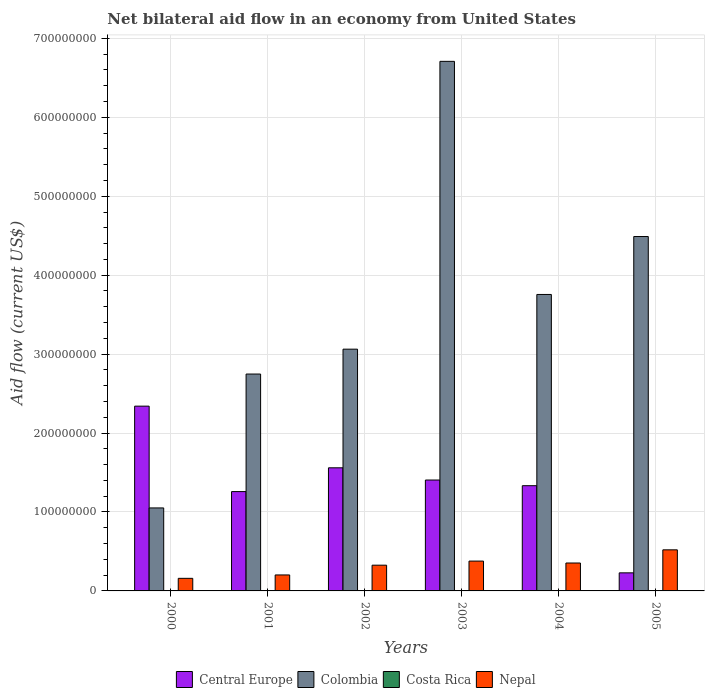Are the number of bars per tick equal to the number of legend labels?
Offer a very short reply. No. How many bars are there on the 5th tick from the left?
Your answer should be very brief. 3. What is the label of the 2nd group of bars from the left?
Your answer should be compact. 2001. What is the net bilateral aid flow in Colombia in 2002?
Your answer should be very brief. 3.06e+08. Across all years, what is the maximum net bilateral aid flow in Central Europe?
Ensure brevity in your answer.  2.34e+08. Across all years, what is the minimum net bilateral aid flow in Central Europe?
Make the answer very short. 2.29e+07. What is the total net bilateral aid flow in Costa Rica in the graph?
Give a very brief answer. 0. What is the difference between the net bilateral aid flow in Colombia in 2001 and that in 2004?
Give a very brief answer. -1.01e+08. What is the difference between the net bilateral aid flow in Colombia in 2000 and the net bilateral aid flow in Costa Rica in 2004?
Provide a short and direct response. 1.05e+08. In the year 2003, what is the difference between the net bilateral aid flow in Colombia and net bilateral aid flow in Nepal?
Provide a succinct answer. 6.33e+08. In how many years, is the net bilateral aid flow in Costa Rica greater than 300000000 US$?
Provide a succinct answer. 0. What is the ratio of the net bilateral aid flow in Colombia in 2001 to that in 2002?
Provide a short and direct response. 0.9. Is the net bilateral aid flow in Central Europe in 2000 less than that in 2002?
Make the answer very short. No. What is the difference between the highest and the second highest net bilateral aid flow in Nepal?
Give a very brief answer. 1.42e+07. What is the difference between the highest and the lowest net bilateral aid flow in Nepal?
Ensure brevity in your answer.  3.61e+07. In how many years, is the net bilateral aid flow in Costa Rica greater than the average net bilateral aid flow in Costa Rica taken over all years?
Your answer should be compact. 0. Is the sum of the net bilateral aid flow in Nepal in 2000 and 2004 greater than the maximum net bilateral aid flow in Central Europe across all years?
Offer a very short reply. No. Are all the bars in the graph horizontal?
Offer a very short reply. No. What is the difference between two consecutive major ticks on the Y-axis?
Your answer should be compact. 1.00e+08. Does the graph contain any zero values?
Keep it short and to the point. Yes. Does the graph contain grids?
Ensure brevity in your answer.  Yes. Where does the legend appear in the graph?
Make the answer very short. Bottom center. What is the title of the graph?
Provide a succinct answer. Net bilateral aid flow in an economy from United States. Does "Latvia" appear as one of the legend labels in the graph?
Your answer should be very brief. No. What is the label or title of the X-axis?
Keep it short and to the point. Years. What is the Aid flow (current US$) of Central Europe in 2000?
Provide a short and direct response. 2.34e+08. What is the Aid flow (current US$) in Colombia in 2000?
Your response must be concise. 1.05e+08. What is the Aid flow (current US$) in Costa Rica in 2000?
Offer a terse response. 0. What is the Aid flow (current US$) of Nepal in 2000?
Your answer should be compact. 1.60e+07. What is the Aid flow (current US$) of Central Europe in 2001?
Your response must be concise. 1.26e+08. What is the Aid flow (current US$) of Colombia in 2001?
Ensure brevity in your answer.  2.75e+08. What is the Aid flow (current US$) in Nepal in 2001?
Offer a very short reply. 2.02e+07. What is the Aid flow (current US$) of Central Europe in 2002?
Make the answer very short. 1.56e+08. What is the Aid flow (current US$) in Colombia in 2002?
Offer a very short reply. 3.06e+08. What is the Aid flow (current US$) in Nepal in 2002?
Offer a very short reply. 3.26e+07. What is the Aid flow (current US$) of Central Europe in 2003?
Offer a terse response. 1.40e+08. What is the Aid flow (current US$) in Colombia in 2003?
Give a very brief answer. 6.71e+08. What is the Aid flow (current US$) of Costa Rica in 2003?
Make the answer very short. 0. What is the Aid flow (current US$) in Nepal in 2003?
Keep it short and to the point. 3.78e+07. What is the Aid flow (current US$) of Central Europe in 2004?
Your response must be concise. 1.33e+08. What is the Aid flow (current US$) in Colombia in 2004?
Keep it short and to the point. 3.76e+08. What is the Aid flow (current US$) in Costa Rica in 2004?
Offer a terse response. 0. What is the Aid flow (current US$) of Nepal in 2004?
Your answer should be very brief. 3.54e+07. What is the Aid flow (current US$) in Central Europe in 2005?
Provide a short and direct response. 2.29e+07. What is the Aid flow (current US$) in Colombia in 2005?
Provide a short and direct response. 4.49e+08. What is the Aid flow (current US$) of Costa Rica in 2005?
Keep it short and to the point. 0. What is the Aid flow (current US$) in Nepal in 2005?
Your answer should be compact. 5.20e+07. Across all years, what is the maximum Aid flow (current US$) in Central Europe?
Give a very brief answer. 2.34e+08. Across all years, what is the maximum Aid flow (current US$) in Colombia?
Your response must be concise. 6.71e+08. Across all years, what is the maximum Aid flow (current US$) of Nepal?
Your response must be concise. 5.20e+07. Across all years, what is the minimum Aid flow (current US$) in Central Europe?
Your answer should be very brief. 2.29e+07. Across all years, what is the minimum Aid flow (current US$) of Colombia?
Make the answer very short. 1.05e+08. Across all years, what is the minimum Aid flow (current US$) of Nepal?
Offer a very short reply. 1.60e+07. What is the total Aid flow (current US$) of Central Europe in the graph?
Your answer should be compact. 8.13e+08. What is the total Aid flow (current US$) of Colombia in the graph?
Ensure brevity in your answer.  2.18e+09. What is the total Aid flow (current US$) of Nepal in the graph?
Your response must be concise. 1.94e+08. What is the difference between the Aid flow (current US$) in Central Europe in 2000 and that in 2001?
Offer a very short reply. 1.08e+08. What is the difference between the Aid flow (current US$) in Colombia in 2000 and that in 2001?
Give a very brief answer. -1.70e+08. What is the difference between the Aid flow (current US$) in Nepal in 2000 and that in 2001?
Offer a terse response. -4.28e+06. What is the difference between the Aid flow (current US$) of Central Europe in 2000 and that in 2002?
Give a very brief answer. 7.81e+07. What is the difference between the Aid flow (current US$) of Colombia in 2000 and that in 2002?
Your answer should be compact. -2.01e+08. What is the difference between the Aid flow (current US$) in Nepal in 2000 and that in 2002?
Offer a terse response. -1.66e+07. What is the difference between the Aid flow (current US$) in Central Europe in 2000 and that in 2003?
Your response must be concise. 9.36e+07. What is the difference between the Aid flow (current US$) of Colombia in 2000 and that in 2003?
Your response must be concise. -5.66e+08. What is the difference between the Aid flow (current US$) of Nepal in 2000 and that in 2003?
Provide a succinct answer. -2.18e+07. What is the difference between the Aid flow (current US$) of Central Europe in 2000 and that in 2004?
Your answer should be compact. 1.01e+08. What is the difference between the Aid flow (current US$) of Colombia in 2000 and that in 2004?
Make the answer very short. -2.70e+08. What is the difference between the Aid flow (current US$) in Nepal in 2000 and that in 2004?
Make the answer very short. -1.94e+07. What is the difference between the Aid flow (current US$) in Central Europe in 2000 and that in 2005?
Offer a very short reply. 2.11e+08. What is the difference between the Aid flow (current US$) in Colombia in 2000 and that in 2005?
Provide a succinct answer. -3.44e+08. What is the difference between the Aid flow (current US$) of Nepal in 2000 and that in 2005?
Offer a very short reply. -3.61e+07. What is the difference between the Aid flow (current US$) in Central Europe in 2001 and that in 2002?
Ensure brevity in your answer.  -3.01e+07. What is the difference between the Aid flow (current US$) of Colombia in 2001 and that in 2002?
Offer a terse response. -3.15e+07. What is the difference between the Aid flow (current US$) of Nepal in 2001 and that in 2002?
Your answer should be compact. -1.24e+07. What is the difference between the Aid flow (current US$) in Central Europe in 2001 and that in 2003?
Your answer should be compact. -1.46e+07. What is the difference between the Aid flow (current US$) of Colombia in 2001 and that in 2003?
Ensure brevity in your answer.  -3.96e+08. What is the difference between the Aid flow (current US$) in Nepal in 2001 and that in 2003?
Offer a terse response. -1.76e+07. What is the difference between the Aid flow (current US$) of Central Europe in 2001 and that in 2004?
Give a very brief answer. -7.45e+06. What is the difference between the Aid flow (current US$) in Colombia in 2001 and that in 2004?
Your response must be concise. -1.01e+08. What is the difference between the Aid flow (current US$) in Nepal in 2001 and that in 2004?
Give a very brief answer. -1.51e+07. What is the difference between the Aid flow (current US$) of Central Europe in 2001 and that in 2005?
Provide a succinct answer. 1.03e+08. What is the difference between the Aid flow (current US$) of Colombia in 2001 and that in 2005?
Offer a terse response. -1.74e+08. What is the difference between the Aid flow (current US$) in Nepal in 2001 and that in 2005?
Keep it short and to the point. -3.18e+07. What is the difference between the Aid flow (current US$) of Central Europe in 2002 and that in 2003?
Ensure brevity in your answer.  1.55e+07. What is the difference between the Aid flow (current US$) in Colombia in 2002 and that in 2003?
Ensure brevity in your answer.  -3.65e+08. What is the difference between the Aid flow (current US$) of Nepal in 2002 and that in 2003?
Offer a terse response. -5.20e+06. What is the difference between the Aid flow (current US$) in Central Europe in 2002 and that in 2004?
Your response must be concise. 2.27e+07. What is the difference between the Aid flow (current US$) in Colombia in 2002 and that in 2004?
Provide a succinct answer. -6.93e+07. What is the difference between the Aid flow (current US$) of Nepal in 2002 and that in 2004?
Give a very brief answer. -2.77e+06. What is the difference between the Aid flow (current US$) in Central Europe in 2002 and that in 2005?
Ensure brevity in your answer.  1.33e+08. What is the difference between the Aid flow (current US$) of Colombia in 2002 and that in 2005?
Offer a very short reply. -1.43e+08. What is the difference between the Aid flow (current US$) in Nepal in 2002 and that in 2005?
Ensure brevity in your answer.  -1.94e+07. What is the difference between the Aid flow (current US$) in Central Europe in 2003 and that in 2004?
Make the answer very short. 7.19e+06. What is the difference between the Aid flow (current US$) in Colombia in 2003 and that in 2004?
Offer a very short reply. 2.95e+08. What is the difference between the Aid flow (current US$) of Nepal in 2003 and that in 2004?
Offer a very short reply. 2.43e+06. What is the difference between the Aid flow (current US$) of Central Europe in 2003 and that in 2005?
Offer a very short reply. 1.18e+08. What is the difference between the Aid flow (current US$) in Colombia in 2003 and that in 2005?
Your answer should be compact. 2.22e+08. What is the difference between the Aid flow (current US$) of Nepal in 2003 and that in 2005?
Keep it short and to the point. -1.42e+07. What is the difference between the Aid flow (current US$) in Central Europe in 2004 and that in 2005?
Offer a terse response. 1.10e+08. What is the difference between the Aid flow (current US$) in Colombia in 2004 and that in 2005?
Your response must be concise. -7.34e+07. What is the difference between the Aid flow (current US$) of Nepal in 2004 and that in 2005?
Give a very brief answer. -1.67e+07. What is the difference between the Aid flow (current US$) of Central Europe in 2000 and the Aid flow (current US$) of Colombia in 2001?
Provide a succinct answer. -4.07e+07. What is the difference between the Aid flow (current US$) in Central Europe in 2000 and the Aid flow (current US$) in Nepal in 2001?
Offer a terse response. 2.14e+08. What is the difference between the Aid flow (current US$) in Colombia in 2000 and the Aid flow (current US$) in Nepal in 2001?
Ensure brevity in your answer.  8.49e+07. What is the difference between the Aid flow (current US$) in Central Europe in 2000 and the Aid flow (current US$) in Colombia in 2002?
Make the answer very short. -7.22e+07. What is the difference between the Aid flow (current US$) of Central Europe in 2000 and the Aid flow (current US$) of Nepal in 2002?
Make the answer very short. 2.01e+08. What is the difference between the Aid flow (current US$) in Colombia in 2000 and the Aid flow (current US$) in Nepal in 2002?
Make the answer very short. 7.25e+07. What is the difference between the Aid flow (current US$) in Central Europe in 2000 and the Aid flow (current US$) in Colombia in 2003?
Make the answer very short. -4.37e+08. What is the difference between the Aid flow (current US$) of Central Europe in 2000 and the Aid flow (current US$) of Nepal in 2003?
Give a very brief answer. 1.96e+08. What is the difference between the Aid flow (current US$) of Colombia in 2000 and the Aid flow (current US$) of Nepal in 2003?
Make the answer very short. 6.73e+07. What is the difference between the Aid flow (current US$) of Central Europe in 2000 and the Aid flow (current US$) of Colombia in 2004?
Your response must be concise. -1.42e+08. What is the difference between the Aid flow (current US$) of Central Europe in 2000 and the Aid flow (current US$) of Nepal in 2004?
Your answer should be compact. 1.99e+08. What is the difference between the Aid flow (current US$) of Colombia in 2000 and the Aid flow (current US$) of Nepal in 2004?
Offer a very short reply. 6.98e+07. What is the difference between the Aid flow (current US$) in Central Europe in 2000 and the Aid flow (current US$) in Colombia in 2005?
Provide a succinct answer. -2.15e+08. What is the difference between the Aid flow (current US$) in Central Europe in 2000 and the Aid flow (current US$) in Nepal in 2005?
Your response must be concise. 1.82e+08. What is the difference between the Aid flow (current US$) of Colombia in 2000 and the Aid flow (current US$) of Nepal in 2005?
Keep it short and to the point. 5.31e+07. What is the difference between the Aid flow (current US$) in Central Europe in 2001 and the Aid flow (current US$) in Colombia in 2002?
Offer a very short reply. -1.80e+08. What is the difference between the Aid flow (current US$) in Central Europe in 2001 and the Aid flow (current US$) in Nepal in 2002?
Provide a succinct answer. 9.32e+07. What is the difference between the Aid flow (current US$) of Colombia in 2001 and the Aid flow (current US$) of Nepal in 2002?
Your answer should be compact. 2.42e+08. What is the difference between the Aid flow (current US$) in Central Europe in 2001 and the Aid flow (current US$) in Colombia in 2003?
Your answer should be compact. -5.45e+08. What is the difference between the Aid flow (current US$) in Central Europe in 2001 and the Aid flow (current US$) in Nepal in 2003?
Your response must be concise. 8.80e+07. What is the difference between the Aid flow (current US$) of Colombia in 2001 and the Aid flow (current US$) of Nepal in 2003?
Offer a very short reply. 2.37e+08. What is the difference between the Aid flow (current US$) in Central Europe in 2001 and the Aid flow (current US$) in Colombia in 2004?
Your response must be concise. -2.50e+08. What is the difference between the Aid flow (current US$) in Central Europe in 2001 and the Aid flow (current US$) in Nepal in 2004?
Your answer should be compact. 9.05e+07. What is the difference between the Aid flow (current US$) in Colombia in 2001 and the Aid flow (current US$) in Nepal in 2004?
Ensure brevity in your answer.  2.39e+08. What is the difference between the Aid flow (current US$) of Central Europe in 2001 and the Aid flow (current US$) of Colombia in 2005?
Keep it short and to the point. -3.23e+08. What is the difference between the Aid flow (current US$) of Central Europe in 2001 and the Aid flow (current US$) of Nepal in 2005?
Provide a succinct answer. 7.38e+07. What is the difference between the Aid flow (current US$) of Colombia in 2001 and the Aid flow (current US$) of Nepal in 2005?
Ensure brevity in your answer.  2.23e+08. What is the difference between the Aid flow (current US$) of Central Europe in 2002 and the Aid flow (current US$) of Colombia in 2003?
Give a very brief answer. -5.15e+08. What is the difference between the Aid flow (current US$) in Central Europe in 2002 and the Aid flow (current US$) in Nepal in 2003?
Provide a short and direct response. 1.18e+08. What is the difference between the Aid flow (current US$) of Colombia in 2002 and the Aid flow (current US$) of Nepal in 2003?
Keep it short and to the point. 2.68e+08. What is the difference between the Aid flow (current US$) in Central Europe in 2002 and the Aid flow (current US$) in Colombia in 2004?
Make the answer very short. -2.20e+08. What is the difference between the Aid flow (current US$) in Central Europe in 2002 and the Aid flow (current US$) in Nepal in 2004?
Provide a succinct answer. 1.21e+08. What is the difference between the Aid flow (current US$) in Colombia in 2002 and the Aid flow (current US$) in Nepal in 2004?
Keep it short and to the point. 2.71e+08. What is the difference between the Aid flow (current US$) in Central Europe in 2002 and the Aid flow (current US$) in Colombia in 2005?
Provide a short and direct response. -2.93e+08. What is the difference between the Aid flow (current US$) in Central Europe in 2002 and the Aid flow (current US$) in Nepal in 2005?
Your response must be concise. 1.04e+08. What is the difference between the Aid flow (current US$) of Colombia in 2002 and the Aid flow (current US$) of Nepal in 2005?
Your answer should be very brief. 2.54e+08. What is the difference between the Aid flow (current US$) of Central Europe in 2003 and the Aid flow (current US$) of Colombia in 2004?
Your answer should be compact. -2.35e+08. What is the difference between the Aid flow (current US$) of Central Europe in 2003 and the Aid flow (current US$) of Nepal in 2004?
Your response must be concise. 1.05e+08. What is the difference between the Aid flow (current US$) of Colombia in 2003 and the Aid flow (current US$) of Nepal in 2004?
Your answer should be very brief. 6.35e+08. What is the difference between the Aid flow (current US$) of Central Europe in 2003 and the Aid flow (current US$) of Colombia in 2005?
Your answer should be compact. -3.08e+08. What is the difference between the Aid flow (current US$) in Central Europe in 2003 and the Aid flow (current US$) in Nepal in 2005?
Make the answer very short. 8.84e+07. What is the difference between the Aid flow (current US$) of Colombia in 2003 and the Aid flow (current US$) of Nepal in 2005?
Offer a very short reply. 6.19e+08. What is the difference between the Aid flow (current US$) of Central Europe in 2004 and the Aid flow (current US$) of Colombia in 2005?
Give a very brief answer. -3.16e+08. What is the difference between the Aid flow (current US$) in Central Europe in 2004 and the Aid flow (current US$) in Nepal in 2005?
Provide a short and direct response. 8.12e+07. What is the difference between the Aid flow (current US$) of Colombia in 2004 and the Aid flow (current US$) of Nepal in 2005?
Ensure brevity in your answer.  3.24e+08. What is the average Aid flow (current US$) in Central Europe per year?
Your response must be concise. 1.35e+08. What is the average Aid flow (current US$) of Colombia per year?
Make the answer very short. 3.64e+08. What is the average Aid flow (current US$) of Nepal per year?
Provide a short and direct response. 3.23e+07. In the year 2000, what is the difference between the Aid flow (current US$) in Central Europe and Aid flow (current US$) in Colombia?
Provide a short and direct response. 1.29e+08. In the year 2000, what is the difference between the Aid flow (current US$) of Central Europe and Aid flow (current US$) of Nepal?
Give a very brief answer. 2.18e+08. In the year 2000, what is the difference between the Aid flow (current US$) in Colombia and Aid flow (current US$) in Nepal?
Keep it short and to the point. 8.92e+07. In the year 2001, what is the difference between the Aid flow (current US$) of Central Europe and Aid flow (current US$) of Colombia?
Keep it short and to the point. -1.49e+08. In the year 2001, what is the difference between the Aid flow (current US$) in Central Europe and Aid flow (current US$) in Nepal?
Keep it short and to the point. 1.06e+08. In the year 2001, what is the difference between the Aid flow (current US$) in Colombia and Aid flow (current US$) in Nepal?
Give a very brief answer. 2.55e+08. In the year 2002, what is the difference between the Aid flow (current US$) of Central Europe and Aid flow (current US$) of Colombia?
Keep it short and to the point. -1.50e+08. In the year 2002, what is the difference between the Aid flow (current US$) in Central Europe and Aid flow (current US$) in Nepal?
Offer a very short reply. 1.23e+08. In the year 2002, what is the difference between the Aid flow (current US$) of Colombia and Aid flow (current US$) of Nepal?
Your answer should be compact. 2.74e+08. In the year 2003, what is the difference between the Aid flow (current US$) in Central Europe and Aid flow (current US$) in Colombia?
Ensure brevity in your answer.  -5.30e+08. In the year 2003, what is the difference between the Aid flow (current US$) in Central Europe and Aid flow (current US$) in Nepal?
Your response must be concise. 1.03e+08. In the year 2003, what is the difference between the Aid flow (current US$) in Colombia and Aid flow (current US$) in Nepal?
Your answer should be compact. 6.33e+08. In the year 2004, what is the difference between the Aid flow (current US$) in Central Europe and Aid flow (current US$) in Colombia?
Your answer should be very brief. -2.42e+08. In the year 2004, what is the difference between the Aid flow (current US$) of Central Europe and Aid flow (current US$) of Nepal?
Your answer should be very brief. 9.79e+07. In the year 2004, what is the difference between the Aid flow (current US$) in Colombia and Aid flow (current US$) in Nepal?
Offer a very short reply. 3.40e+08. In the year 2005, what is the difference between the Aid flow (current US$) in Central Europe and Aid flow (current US$) in Colombia?
Provide a short and direct response. -4.26e+08. In the year 2005, what is the difference between the Aid flow (current US$) of Central Europe and Aid flow (current US$) of Nepal?
Your response must be concise. -2.92e+07. In the year 2005, what is the difference between the Aid flow (current US$) of Colombia and Aid flow (current US$) of Nepal?
Ensure brevity in your answer.  3.97e+08. What is the ratio of the Aid flow (current US$) of Central Europe in 2000 to that in 2001?
Ensure brevity in your answer.  1.86. What is the ratio of the Aid flow (current US$) of Colombia in 2000 to that in 2001?
Keep it short and to the point. 0.38. What is the ratio of the Aid flow (current US$) of Nepal in 2000 to that in 2001?
Keep it short and to the point. 0.79. What is the ratio of the Aid flow (current US$) of Central Europe in 2000 to that in 2002?
Provide a succinct answer. 1.5. What is the ratio of the Aid flow (current US$) of Colombia in 2000 to that in 2002?
Your answer should be compact. 0.34. What is the ratio of the Aid flow (current US$) in Nepal in 2000 to that in 2002?
Keep it short and to the point. 0.49. What is the ratio of the Aid flow (current US$) of Central Europe in 2000 to that in 2003?
Your response must be concise. 1.67. What is the ratio of the Aid flow (current US$) of Colombia in 2000 to that in 2003?
Make the answer very short. 0.16. What is the ratio of the Aid flow (current US$) in Nepal in 2000 to that in 2003?
Your response must be concise. 0.42. What is the ratio of the Aid flow (current US$) of Central Europe in 2000 to that in 2004?
Your answer should be very brief. 1.76. What is the ratio of the Aid flow (current US$) in Colombia in 2000 to that in 2004?
Your answer should be very brief. 0.28. What is the ratio of the Aid flow (current US$) in Nepal in 2000 to that in 2004?
Ensure brevity in your answer.  0.45. What is the ratio of the Aid flow (current US$) in Central Europe in 2000 to that in 2005?
Provide a short and direct response. 10.23. What is the ratio of the Aid flow (current US$) in Colombia in 2000 to that in 2005?
Provide a short and direct response. 0.23. What is the ratio of the Aid flow (current US$) in Nepal in 2000 to that in 2005?
Provide a succinct answer. 0.31. What is the ratio of the Aid flow (current US$) in Central Europe in 2001 to that in 2002?
Your response must be concise. 0.81. What is the ratio of the Aid flow (current US$) of Colombia in 2001 to that in 2002?
Your response must be concise. 0.9. What is the ratio of the Aid flow (current US$) of Nepal in 2001 to that in 2002?
Your answer should be very brief. 0.62. What is the ratio of the Aid flow (current US$) of Central Europe in 2001 to that in 2003?
Make the answer very short. 0.9. What is the ratio of the Aid flow (current US$) of Colombia in 2001 to that in 2003?
Provide a short and direct response. 0.41. What is the ratio of the Aid flow (current US$) of Nepal in 2001 to that in 2003?
Offer a terse response. 0.54. What is the ratio of the Aid flow (current US$) in Central Europe in 2001 to that in 2004?
Keep it short and to the point. 0.94. What is the ratio of the Aid flow (current US$) in Colombia in 2001 to that in 2004?
Your response must be concise. 0.73. What is the ratio of the Aid flow (current US$) in Nepal in 2001 to that in 2004?
Your answer should be very brief. 0.57. What is the ratio of the Aid flow (current US$) in Central Europe in 2001 to that in 2005?
Provide a short and direct response. 5.5. What is the ratio of the Aid flow (current US$) of Colombia in 2001 to that in 2005?
Give a very brief answer. 0.61. What is the ratio of the Aid flow (current US$) in Nepal in 2001 to that in 2005?
Keep it short and to the point. 0.39. What is the ratio of the Aid flow (current US$) of Central Europe in 2002 to that in 2003?
Your answer should be very brief. 1.11. What is the ratio of the Aid flow (current US$) of Colombia in 2002 to that in 2003?
Keep it short and to the point. 0.46. What is the ratio of the Aid flow (current US$) in Nepal in 2002 to that in 2003?
Your response must be concise. 0.86. What is the ratio of the Aid flow (current US$) in Central Europe in 2002 to that in 2004?
Provide a succinct answer. 1.17. What is the ratio of the Aid flow (current US$) of Colombia in 2002 to that in 2004?
Provide a succinct answer. 0.82. What is the ratio of the Aid flow (current US$) in Nepal in 2002 to that in 2004?
Provide a short and direct response. 0.92. What is the ratio of the Aid flow (current US$) of Central Europe in 2002 to that in 2005?
Your answer should be very brief. 6.81. What is the ratio of the Aid flow (current US$) of Colombia in 2002 to that in 2005?
Provide a succinct answer. 0.68. What is the ratio of the Aid flow (current US$) of Nepal in 2002 to that in 2005?
Your answer should be compact. 0.63. What is the ratio of the Aid flow (current US$) in Central Europe in 2003 to that in 2004?
Your answer should be compact. 1.05. What is the ratio of the Aid flow (current US$) in Colombia in 2003 to that in 2004?
Provide a succinct answer. 1.79. What is the ratio of the Aid flow (current US$) in Nepal in 2003 to that in 2004?
Ensure brevity in your answer.  1.07. What is the ratio of the Aid flow (current US$) of Central Europe in 2003 to that in 2005?
Ensure brevity in your answer.  6.14. What is the ratio of the Aid flow (current US$) in Colombia in 2003 to that in 2005?
Ensure brevity in your answer.  1.49. What is the ratio of the Aid flow (current US$) of Nepal in 2003 to that in 2005?
Your answer should be compact. 0.73. What is the ratio of the Aid flow (current US$) of Central Europe in 2004 to that in 2005?
Offer a very short reply. 5.82. What is the ratio of the Aid flow (current US$) in Colombia in 2004 to that in 2005?
Provide a short and direct response. 0.84. What is the ratio of the Aid flow (current US$) of Nepal in 2004 to that in 2005?
Ensure brevity in your answer.  0.68. What is the difference between the highest and the second highest Aid flow (current US$) of Central Europe?
Your answer should be compact. 7.81e+07. What is the difference between the highest and the second highest Aid flow (current US$) of Colombia?
Keep it short and to the point. 2.22e+08. What is the difference between the highest and the second highest Aid flow (current US$) of Nepal?
Your response must be concise. 1.42e+07. What is the difference between the highest and the lowest Aid flow (current US$) in Central Europe?
Provide a short and direct response. 2.11e+08. What is the difference between the highest and the lowest Aid flow (current US$) of Colombia?
Offer a very short reply. 5.66e+08. What is the difference between the highest and the lowest Aid flow (current US$) of Nepal?
Make the answer very short. 3.61e+07. 